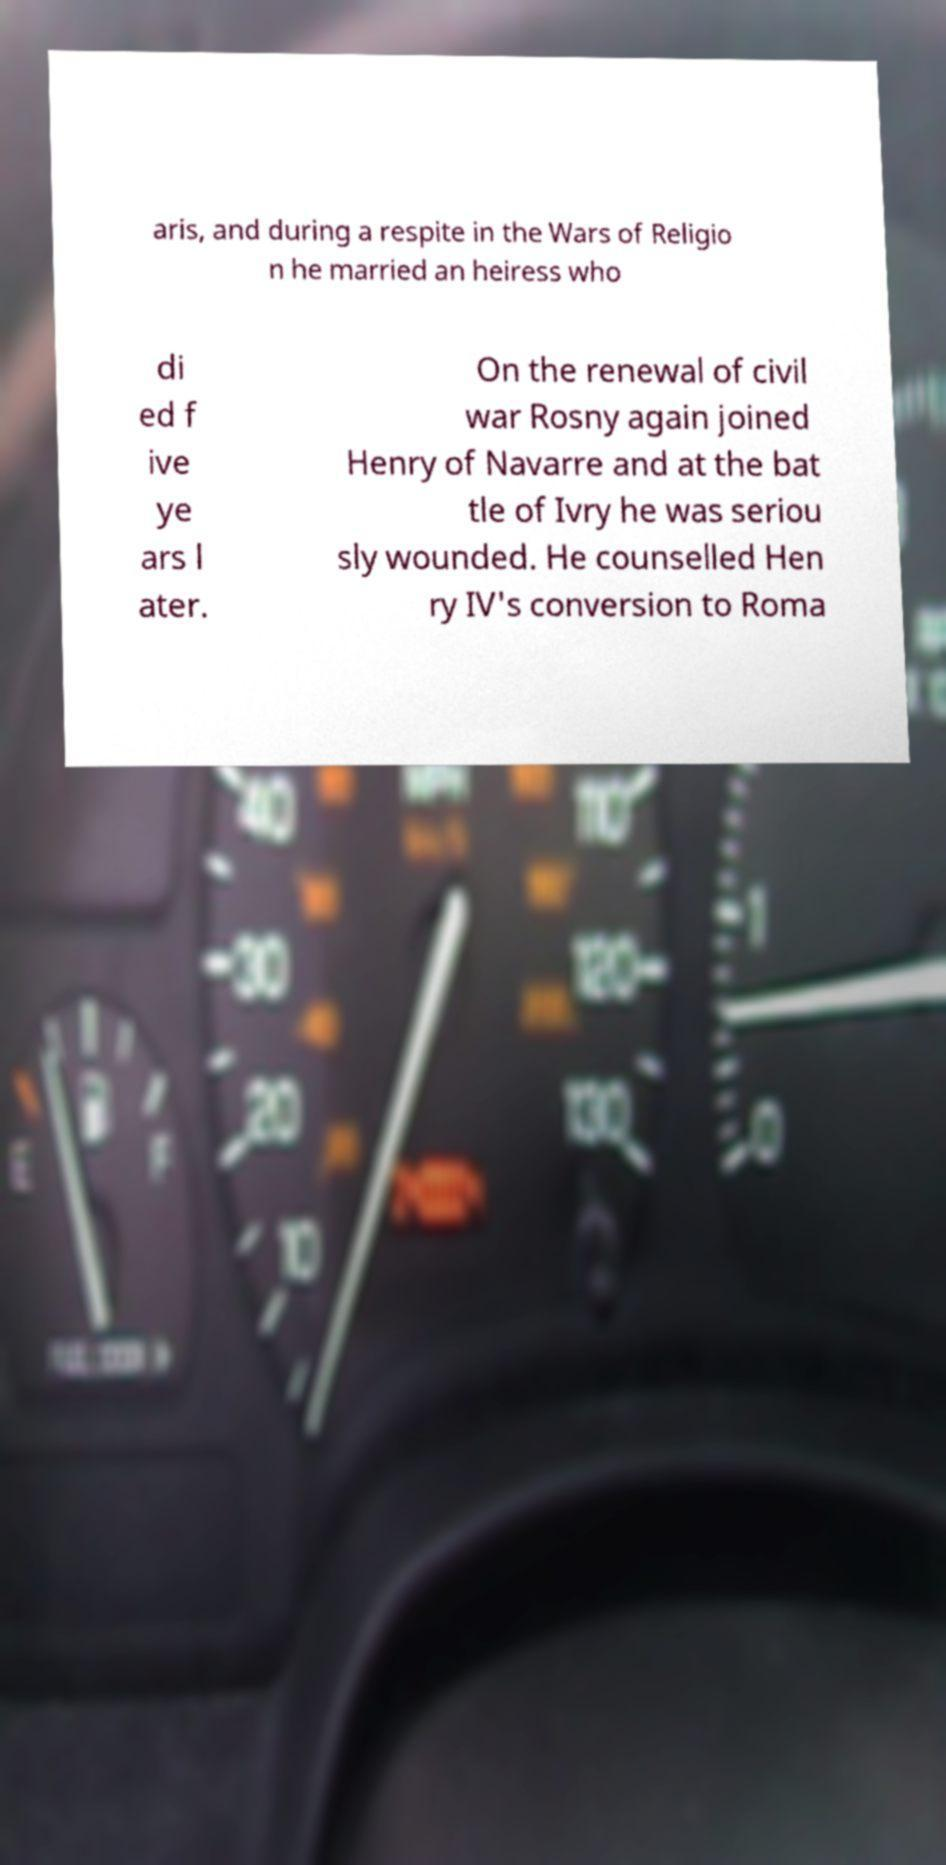For documentation purposes, I need the text within this image transcribed. Could you provide that? aris, and during a respite in the Wars of Religio n he married an heiress who di ed f ive ye ars l ater. On the renewal of civil war Rosny again joined Henry of Navarre and at the bat tle of Ivry he was seriou sly wounded. He counselled Hen ry IV's conversion to Roma 